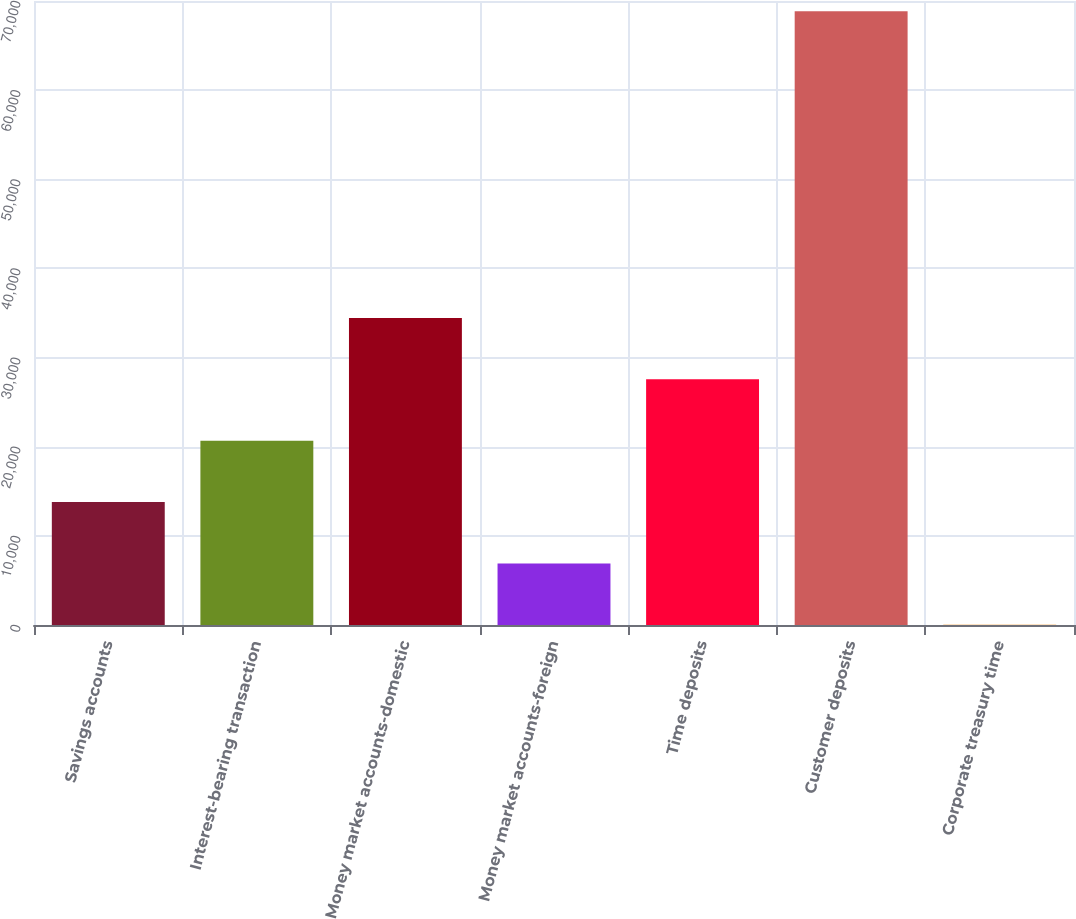Convert chart to OTSL. <chart><loc_0><loc_0><loc_500><loc_500><bar_chart><fcel>Savings accounts<fcel>Interest-bearing transaction<fcel>Money market accounts-domestic<fcel>Money market accounts-foreign<fcel>Time deposits<fcel>Customer deposits<fcel>Corporate treasury time<nl><fcel>13786.4<fcel>20671.1<fcel>34440.5<fcel>6901.7<fcel>27555.8<fcel>68864<fcel>17<nl></chart> 